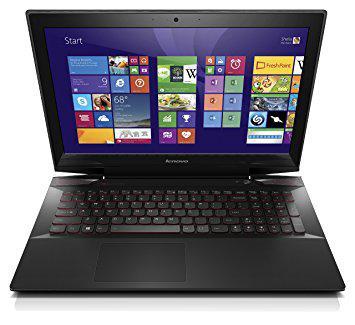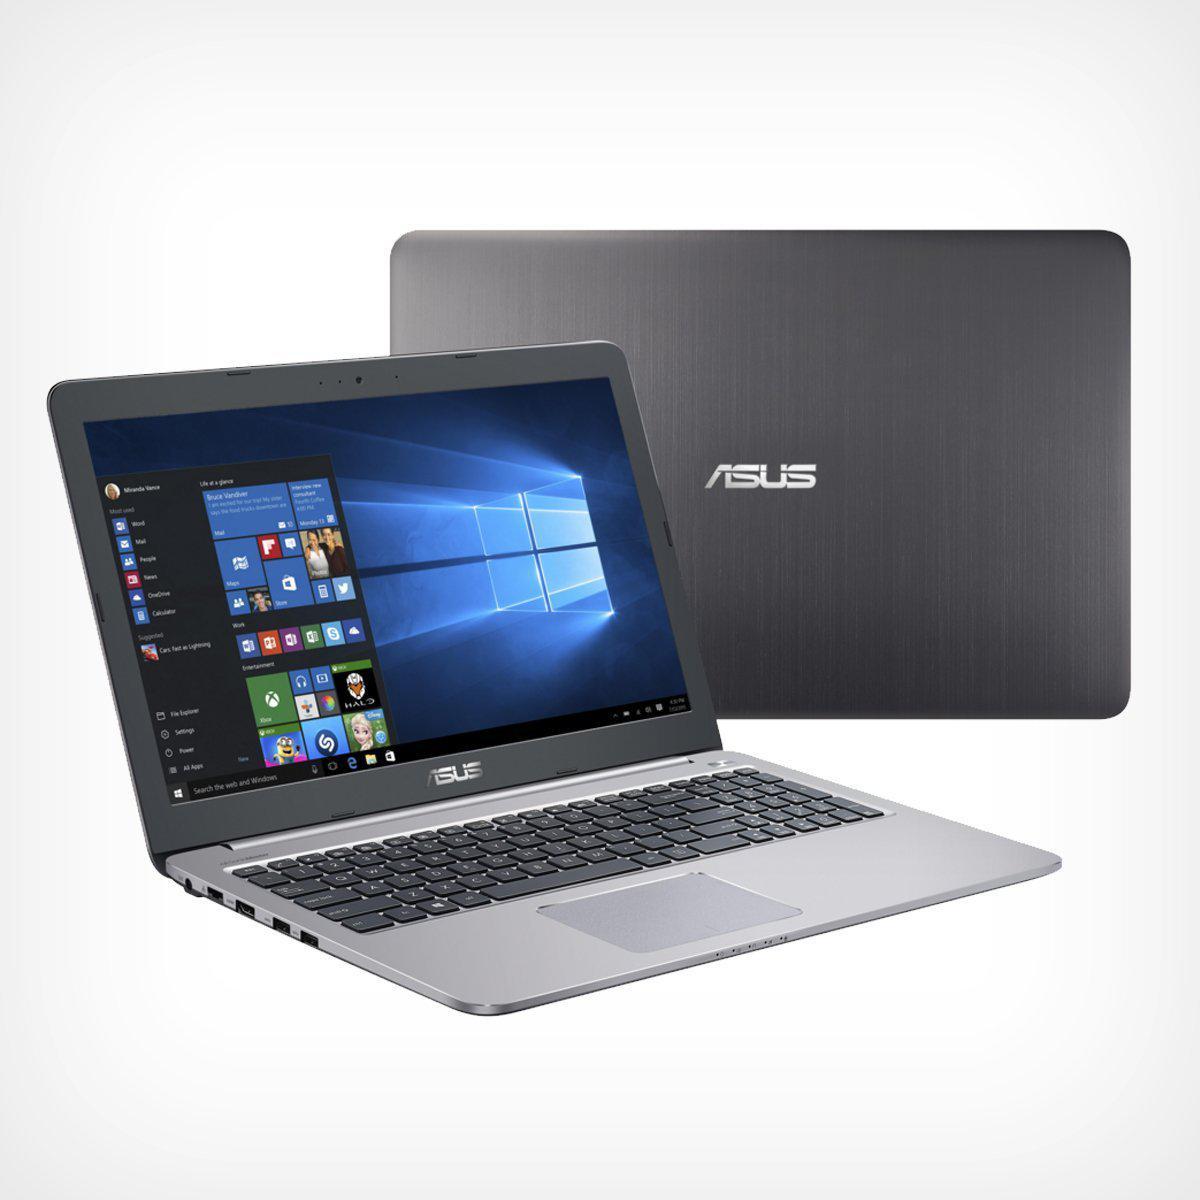The first image is the image on the left, the second image is the image on the right. For the images displayed, is the sentence "There is one laptop shown front and back." factually correct? Answer yes or no. Yes. The first image is the image on the left, the second image is the image on the right. For the images shown, is this caption "In one image there is a laptop computer from the brand hp and the other image has a DELL laptop." true? Answer yes or no. No. 